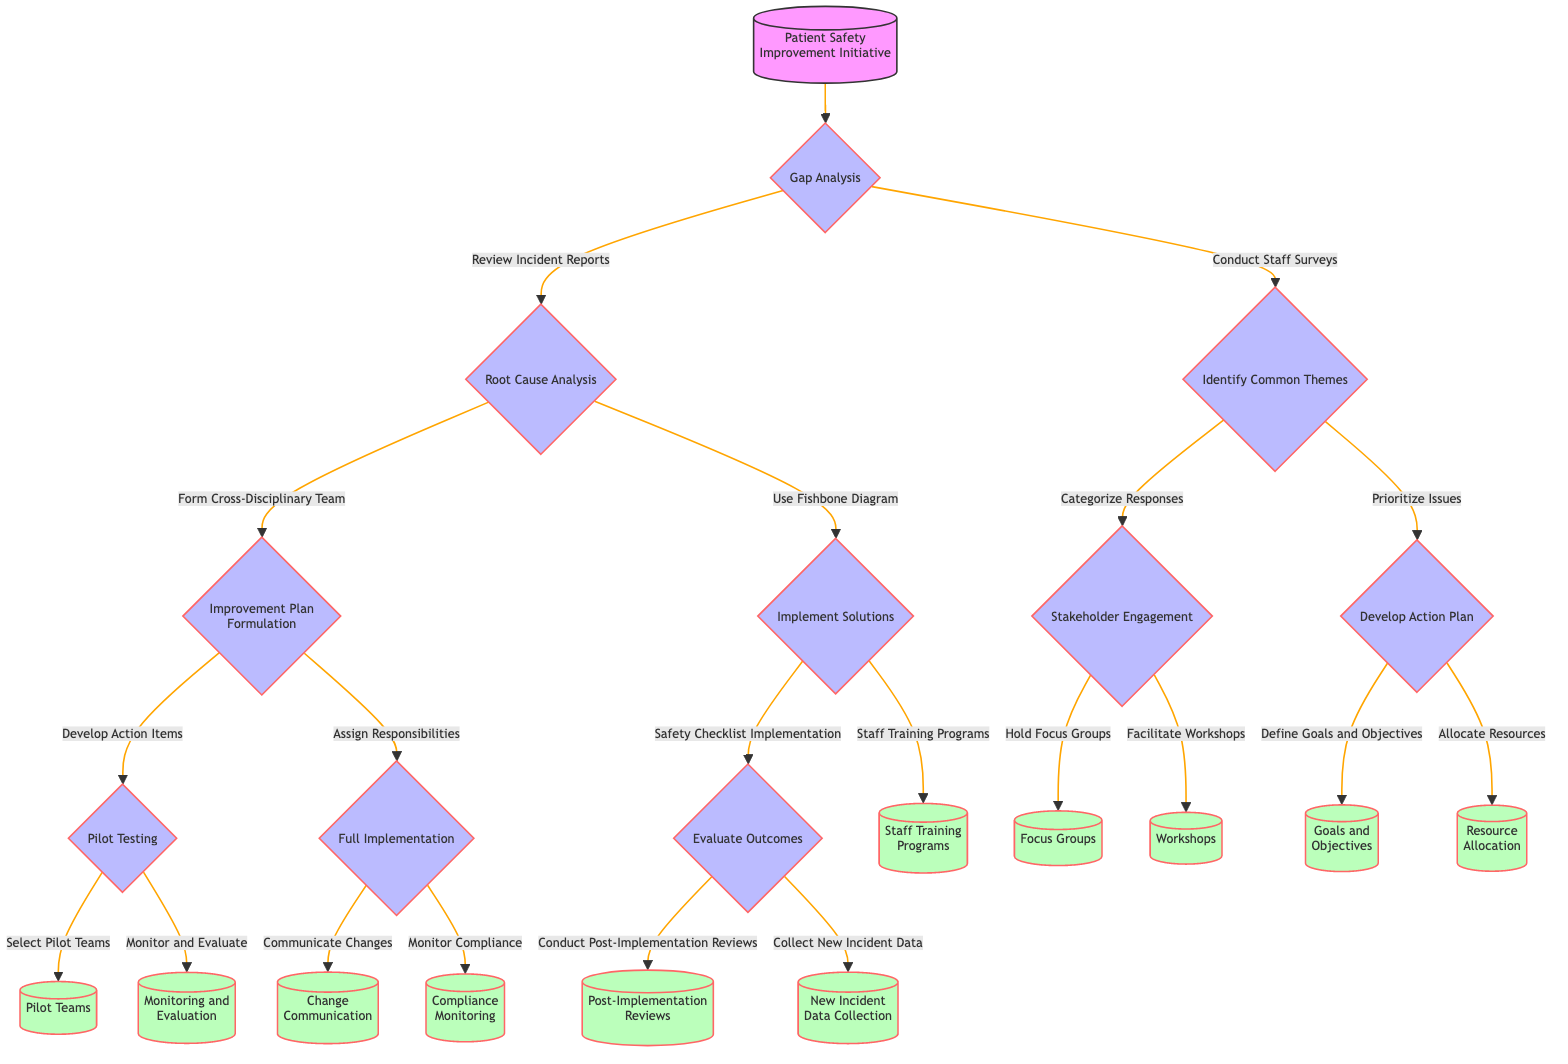What is the first step in the initiative? The diagram starts with the first node, labeled "Gap Analysis," which is the initial action to take in the patient safety improvement initiative.
Answer: Gap Analysis How many options are there after performing Gap Analysis? From the "Gap Analysis" node, there are two choices leading to either "Root Cause Analysis" or "Identify Common Themes." Thus, there are two options.
Answer: 2 What step follows the use of the Fishbone Diagram? The "Fishbone Diagram" leads to "Implement Solutions," as indicated by the flow of the diagram where this node connects next.
Answer: Implement Solutions Which node has the most outgoing connections? Upon examining the diagram, "Full Implementation" has two outgoing connections leading to "Communicate Changes" and "Monitor Compliance," making it the node with the most outgoing connections.
Answer: Full Implementation What is the final step after evaluating outcomes? The final step connected to "Evaluate Outcomes" includes nodes like "Conduct Post-Implementation Reviews" and "Collect New Incident Data," thus these are the concluding actions of this initiative.
Answer: Conduct Post-Implementation Reviews, Collect New Incident Data What choice follows the "Conduct Staff Surveys"? In the decision tree, "Conduct Staff Surveys" leads directly to "Identify Common Themes," which is the next logical step following the survey actions.
Answer: Identify Common Themes After "Categorize Responses," which node follows next? The node "Categorize Responses" leads to "Stakeholder Engagement," making it the immediate subsequent step after categorization.
Answer: Stakeholder Engagement What is the second option after conducting Root Cause Analysis? The second choice following "Root Cause Analysis" after the first option's connection leads to "Use Fishbone Diagram," indicating the flow from root cause assessment.
Answer: Use Fishbone Diagram How many total steps are represented in the diagram? The diagram contains a total of ten step nodes, as identified while counting each labeled action from the start to the end of the flow.
Answer: 10 